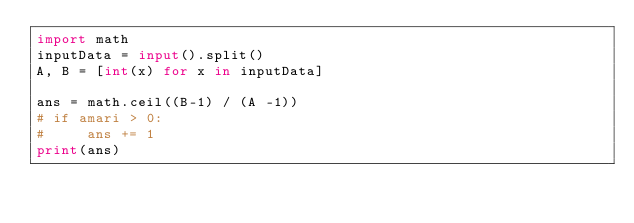<code> <loc_0><loc_0><loc_500><loc_500><_Python_>import math
inputData = input().split()
A, B = [int(x) for x in inputData]

ans = math.ceil((B-1) / (A -1))
# if amari > 0:
#     ans += 1
print(ans)</code> 